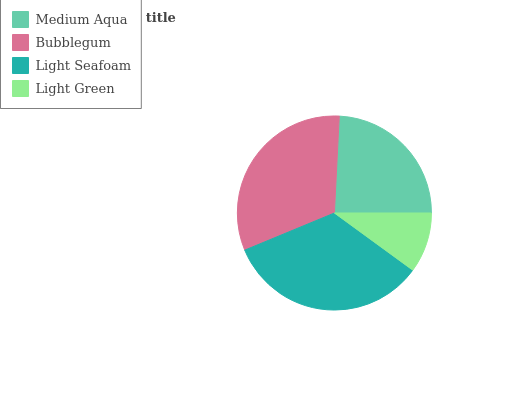Is Light Green the minimum?
Answer yes or no. Yes. Is Light Seafoam the maximum?
Answer yes or no. Yes. Is Bubblegum the minimum?
Answer yes or no. No. Is Bubblegum the maximum?
Answer yes or no. No. Is Bubblegum greater than Medium Aqua?
Answer yes or no. Yes. Is Medium Aqua less than Bubblegum?
Answer yes or no. Yes. Is Medium Aqua greater than Bubblegum?
Answer yes or no. No. Is Bubblegum less than Medium Aqua?
Answer yes or no. No. Is Bubblegum the high median?
Answer yes or no. Yes. Is Medium Aqua the low median?
Answer yes or no. Yes. Is Light Seafoam the high median?
Answer yes or no. No. Is Light Green the low median?
Answer yes or no. No. 